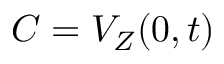<formula> <loc_0><loc_0><loc_500><loc_500>C = V _ { Z } ( 0 , t )</formula> 